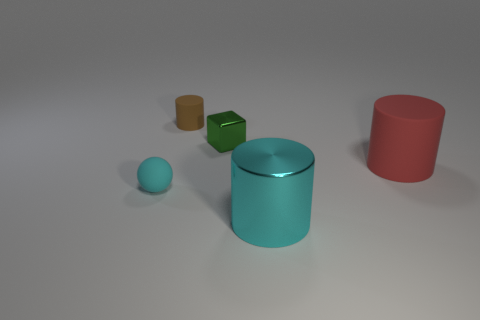Add 1 tiny red metal cubes. How many objects exist? 6 Subtract all cubes. How many objects are left? 4 Subtract 0 gray cubes. How many objects are left? 5 Subtract all matte objects. Subtract all green metal blocks. How many objects are left? 1 Add 3 small brown objects. How many small brown objects are left? 4 Add 3 tiny spheres. How many tiny spheres exist? 4 